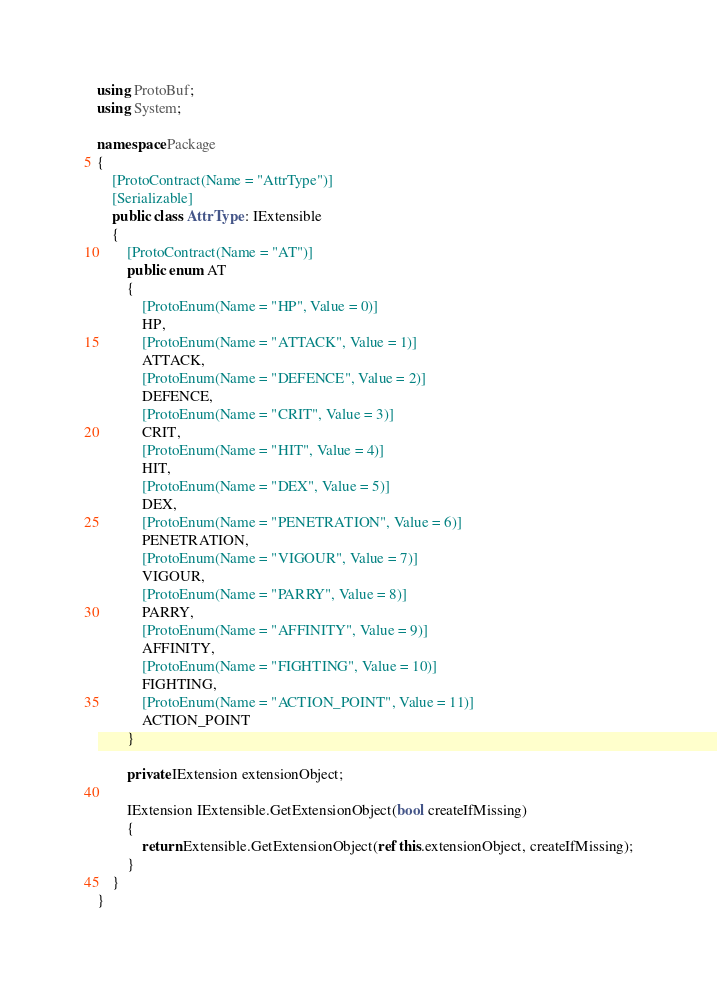<code> <loc_0><loc_0><loc_500><loc_500><_C#_>using ProtoBuf;
using System;

namespace Package
{
	[ProtoContract(Name = "AttrType")]
	[Serializable]
	public class AttrType : IExtensible
	{
		[ProtoContract(Name = "AT")]
		public enum AT
		{
			[ProtoEnum(Name = "HP", Value = 0)]
			HP,
			[ProtoEnum(Name = "ATTACK", Value = 1)]
			ATTACK,
			[ProtoEnum(Name = "DEFENCE", Value = 2)]
			DEFENCE,
			[ProtoEnum(Name = "CRIT", Value = 3)]
			CRIT,
			[ProtoEnum(Name = "HIT", Value = 4)]
			HIT,
			[ProtoEnum(Name = "DEX", Value = 5)]
			DEX,
			[ProtoEnum(Name = "PENETRATION", Value = 6)]
			PENETRATION,
			[ProtoEnum(Name = "VIGOUR", Value = 7)]
			VIGOUR,
			[ProtoEnum(Name = "PARRY", Value = 8)]
			PARRY,
			[ProtoEnum(Name = "AFFINITY", Value = 9)]
			AFFINITY,
			[ProtoEnum(Name = "FIGHTING", Value = 10)]
			FIGHTING,
			[ProtoEnum(Name = "ACTION_POINT", Value = 11)]
			ACTION_POINT
		}

		private IExtension extensionObject;

		IExtension IExtensible.GetExtensionObject(bool createIfMissing)
		{
			return Extensible.GetExtensionObject(ref this.extensionObject, createIfMissing);
		}
	}
}
</code> 